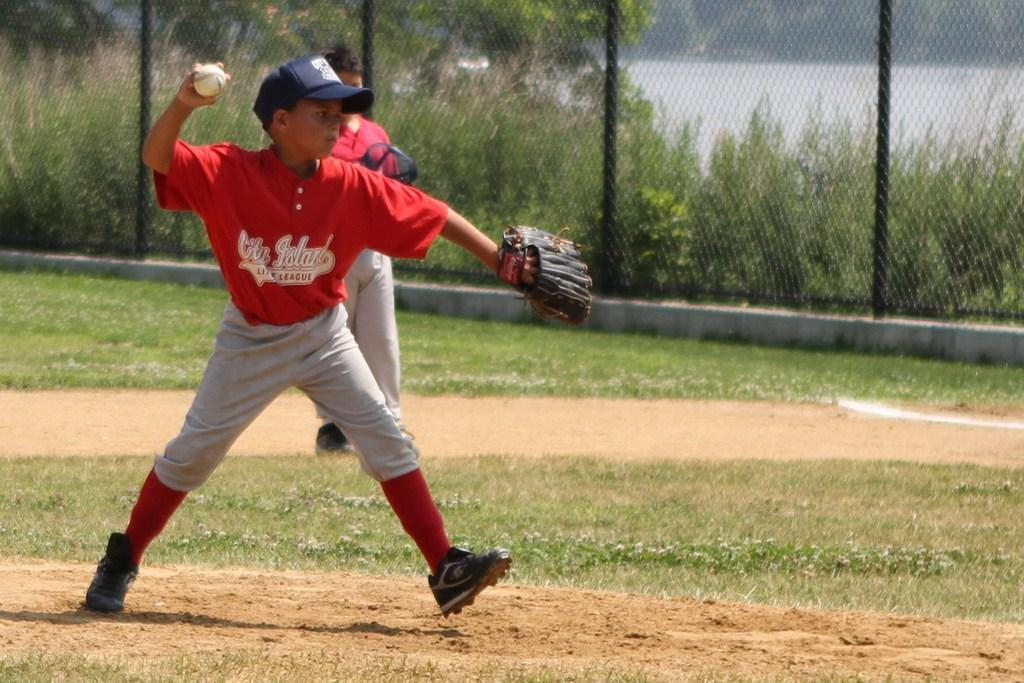Provide a one-sentence caption for the provided image. A young boy in a red and grey strip who plays for City Island Little League throws the baseball. 